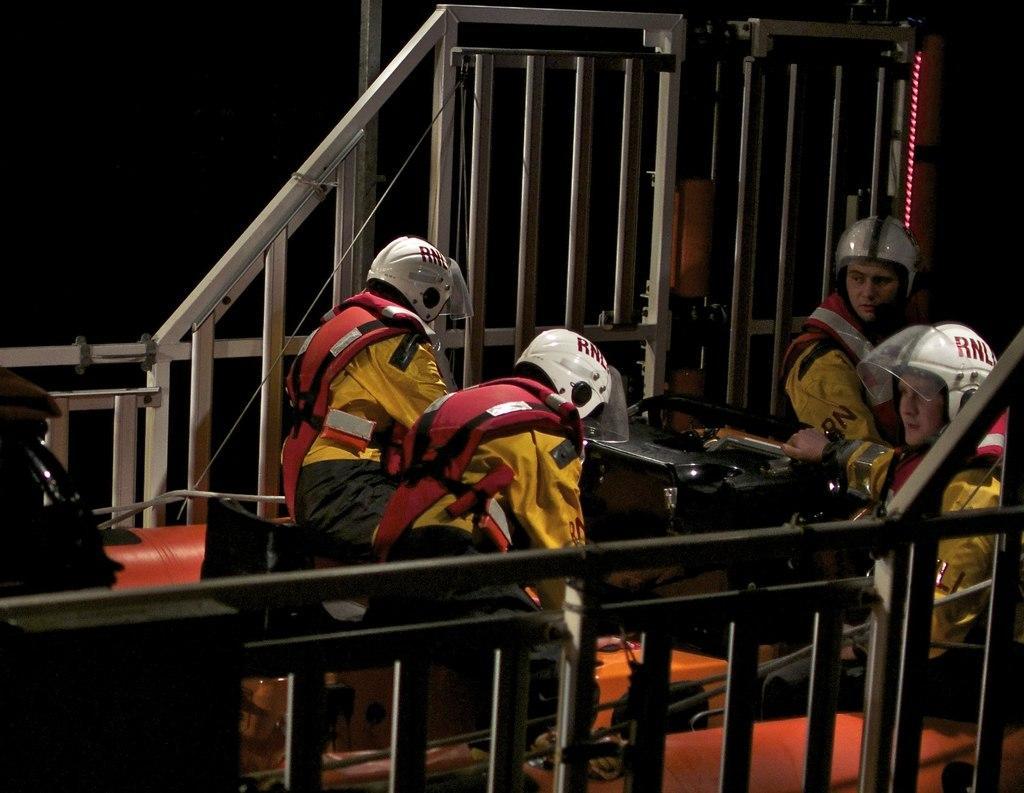Can you describe this image briefly? Here we can see four persons and they wore helmets. And there is a dark background. 